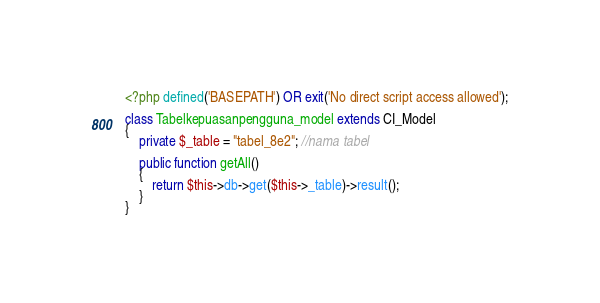<code> <loc_0><loc_0><loc_500><loc_500><_PHP_><?php defined('BASEPATH') OR exit('No direct script access allowed');

class Tabelkepuasanpengguna_model extends CI_Model
{
    private $_table = "tabel_8e2"; //nama tabel

    public function getAll()
    {
        return $this->db->get($this->_table)->result();
    }
}</code> 